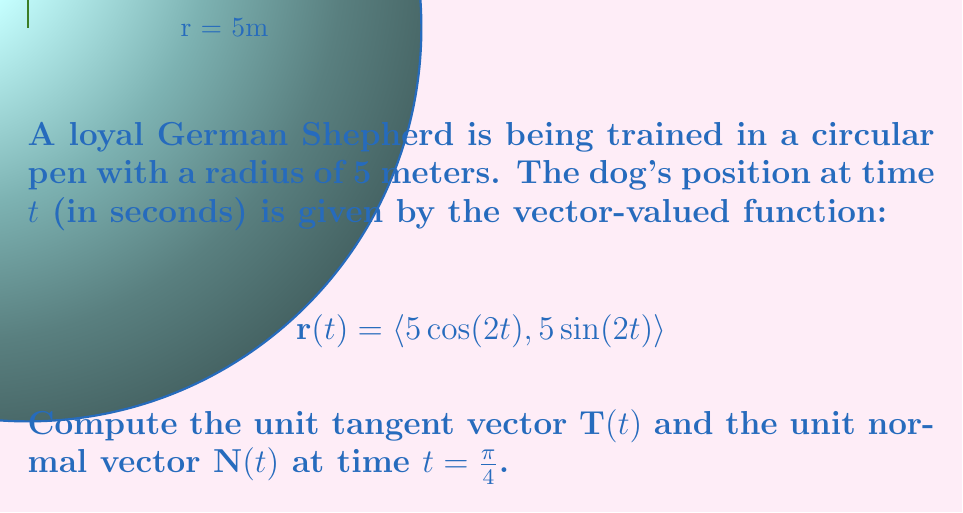Give your solution to this math problem. To find the unit tangent and normal vectors, we'll follow these steps:

1) First, we need to find $\mathbf{r}'(t)$:
   $$\mathbf{r}'(t) = \langle -10\sin(2t), 10\cos(2t) \rangle$$

2) The unit tangent vector is given by:
   $$\mathbf{T}(t) = \frac{\mathbf{r}'(t)}{|\mathbf{r}'(t)|}$$

3) Calculate $|\mathbf{r}'(t)|$:
   $$|\mathbf{r}'(t)| = \sqrt{(-10\sin(2t))^2 + (10\cos(2t))^2} = 10$$

4) Therefore, 
   $$\mathbf{T}(t) = \langle -\sin(2t), \cos(2t) \rangle$$

5) At $t=\frac{\pi}{4}$:
   $$\mathbf{T}(\frac{\pi}{4}) = \langle -\sin(\frac{\pi}{2}), \cos(\frac{\pi}{2}) \rangle = \langle -1, 0 \rangle$$

6) The unit normal vector is given by rotating the tangent vector 90° counterclockwise:
   $$\mathbf{N}(t) = \langle \cos(2t), \sin(2t) \rangle$$

7) At $t=\frac{\pi}{4}$:
   $$\mathbf{N}(\frac{\pi}{4}) = \langle \cos(\frac{\pi}{2}), \sin(\frac{\pi}{2}) \rangle = \langle 0, 1 \rangle$$
Answer: $\mathbf{T}(\frac{\pi}{4}) = \langle -1, 0 \rangle$, $\mathbf{N}(\frac{\pi}{4}) = \langle 0, 1 \rangle$ 